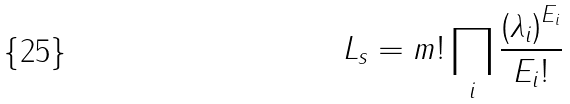<formula> <loc_0><loc_0><loc_500><loc_500>L _ { s } = m ! \prod _ { i } \frac { { \left ( \lambda _ { i } \right ) } ^ { E _ { i } } } { E _ { i } ! }</formula> 